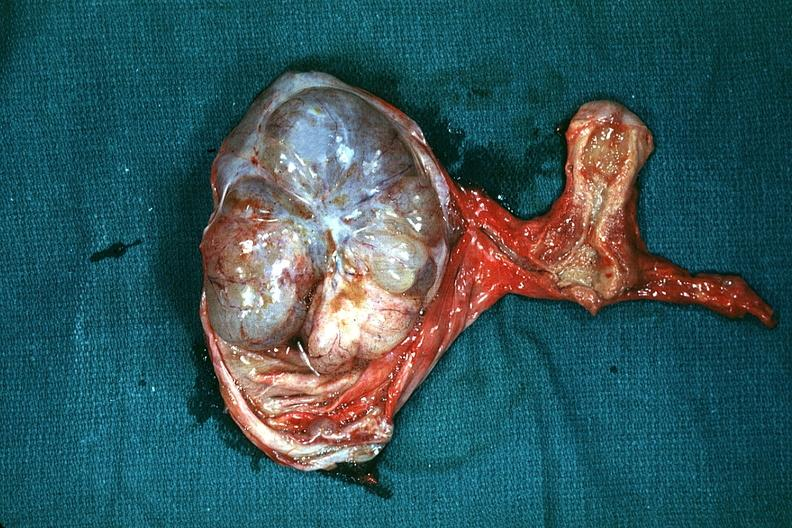where does this belong to?
Answer the question using a single word or phrase. Female reproductive system 